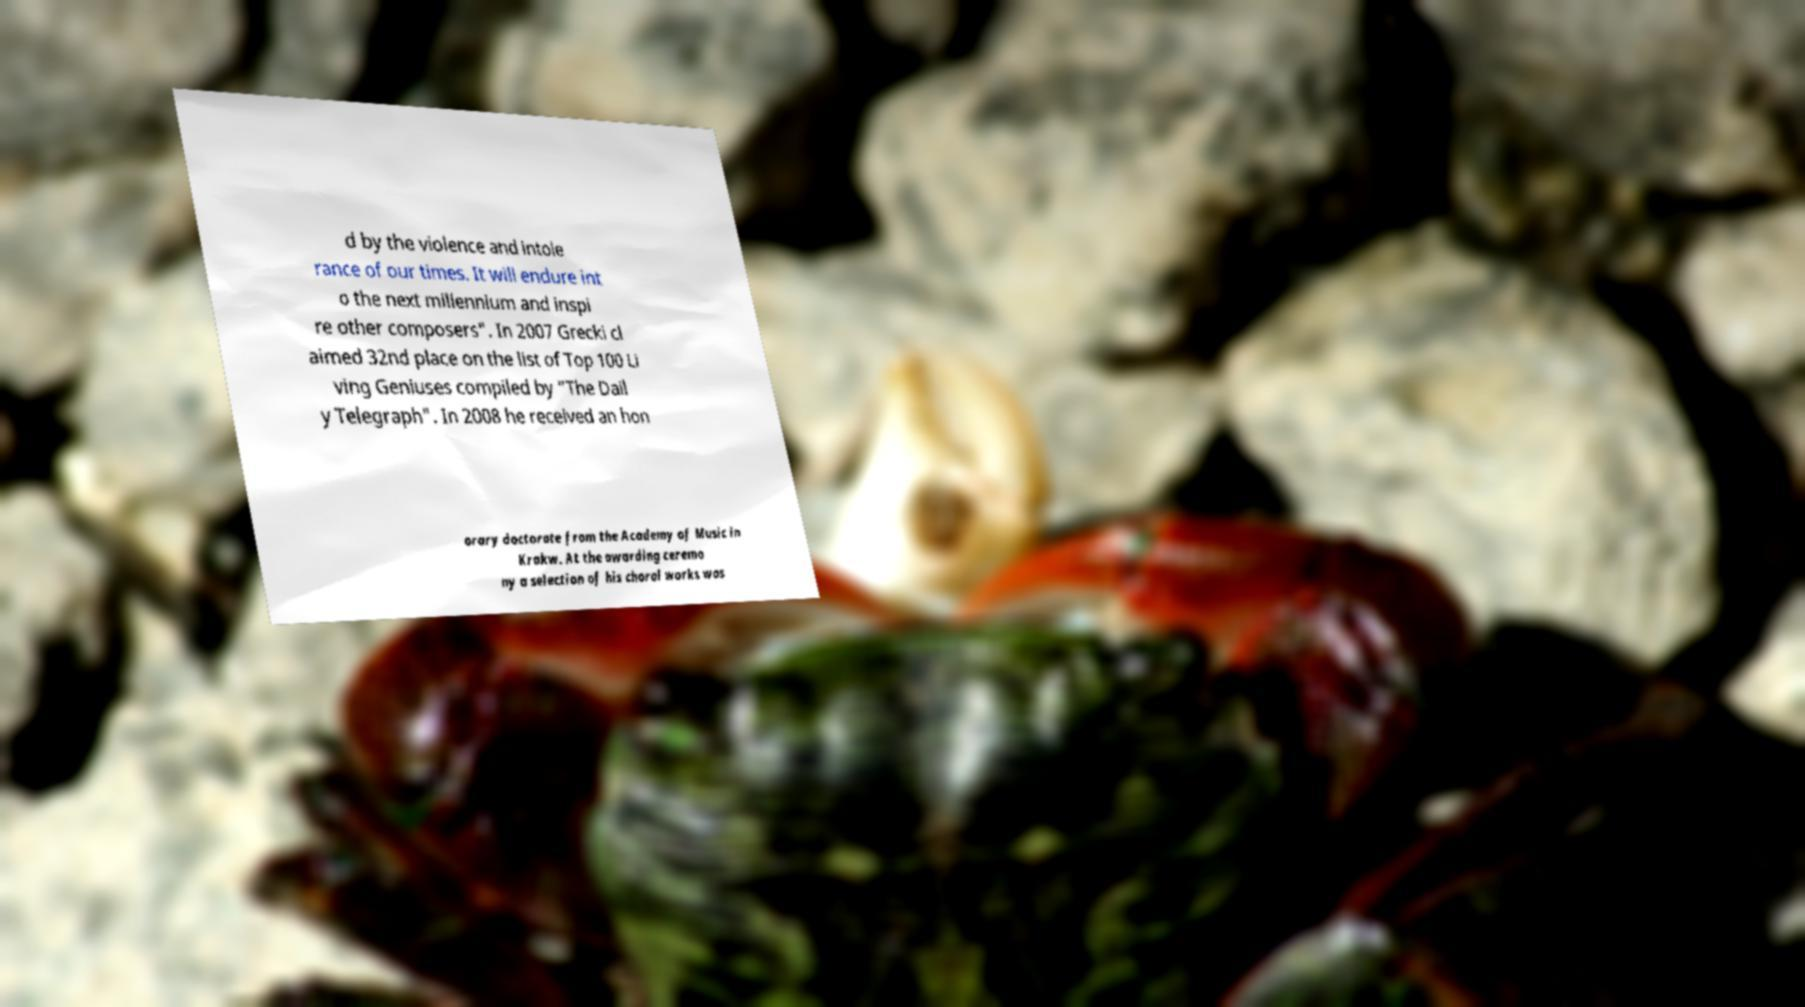I need the written content from this picture converted into text. Can you do that? d by the violence and intole rance of our times. It will endure int o the next millennium and inspi re other composers". In 2007 Grecki cl aimed 32nd place on the list of Top 100 Li ving Geniuses compiled by "The Dail y Telegraph". In 2008 he received an hon orary doctorate from the Academy of Music in Krakw. At the awarding ceremo ny a selection of his choral works was 